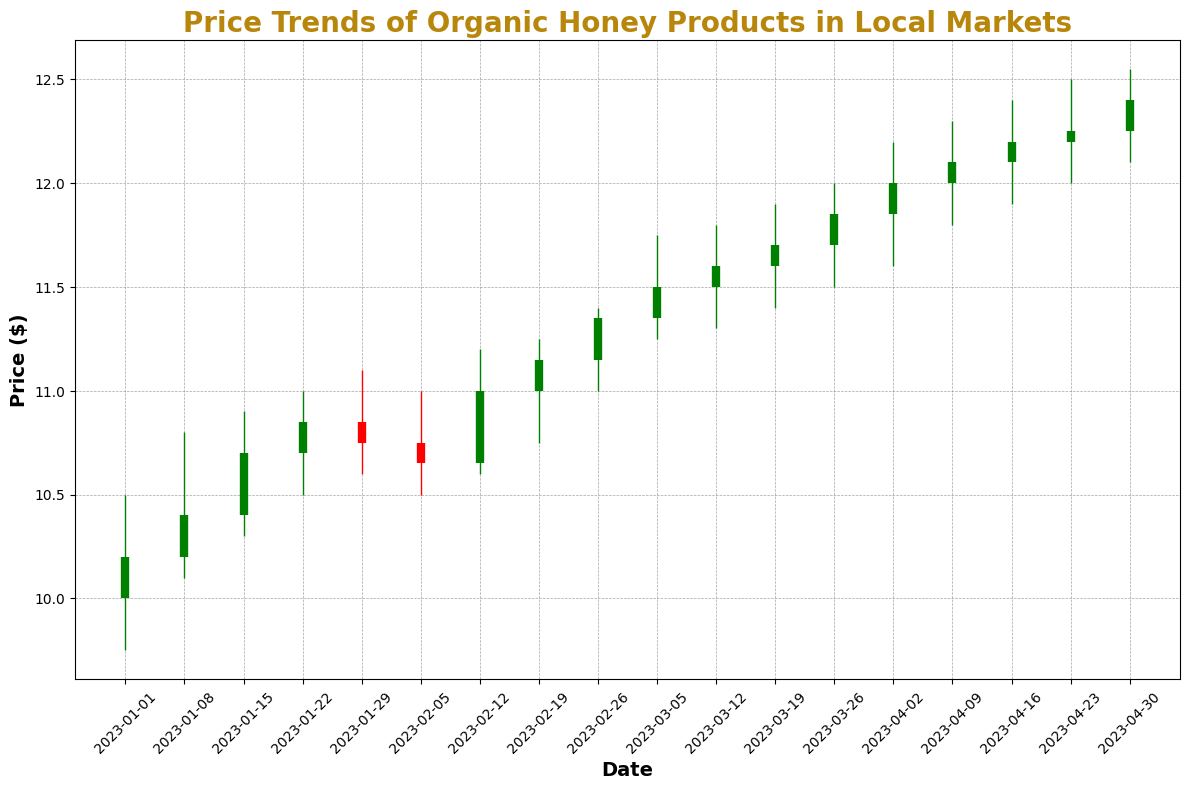What is the price range (difference between the highest and lowest prices) for organic honey products on January 8, 2023? The highest price on January 8, 2023, is $10.80, and the lowest price is $10.10. The difference between the highest and lowest prices is $10.80 - $10.10 = $0.70.
Answer: $0.70 During which week did the closing price exceed the opening price by the largest amount? First, identify the difference between the closing and opening prices for each week. The largest difference is on February 12, 2023, with the closing price at $11.00 and the opening price at $10.65, a difference of $11.00 - $10.65 = $0.35.
Answer: February 12, 2023 Compare the closing prices of January 1 and February 26, 2023. Which one is higher and by how much? The closing price on January 1, 2023, is $10.20 and on February 26, 2023, is $11.35. The difference is $11.35 - $10.20 = $1.15. February 26, 2023 has the higher closing price by $1.15.
Answer: February 26, 2023 by $1.15 What is the trend of the closing prices from January 1 to April 30, 2023? To determine the trend, observe the closing prices over the given period. Starting from $10.20 on January 1 to $12.40 on April 30, the closing prices exhibit a general upward trend.
Answer: Upward Identify the week where the price of organic honey reached its highest level. What was the highest price, and during which week did it occur? Observe the highest prices throughout the weeks. The highest price was $12.55 during the week of April 30, 2023.
Answer: April 30, 2023 at $12.55 Which week had the smallest difference between the highest and lowest prices? Calculate the difference between the highest and lowest prices for each week. The smallest difference is for the week of January 1, 2023, with a difference of $10.50 - $9.75 = $0.75.
Answer: January 1, 2023 When did the first major price increase occur (week where the closing price was significantly higher than the previous week)? By comparing consecutive weeks, the first major increase happened on January 15, 2023. The closing price increased from $10.40 to $10.70, a $0.30 increase from the previous week (January 8).
Answer: January 15, 2023 How many weeks did the closing price stay at or above $11.00? Identify the weeks where the closing price is $11.00 or higher. These weeks are February 12, February 19, February 26, March 5, March 12, March 19, March 26, April 2, April 9, April 16, April 23, April 30. This gives us a total of 12 weeks.
Answer: 12 weeks 